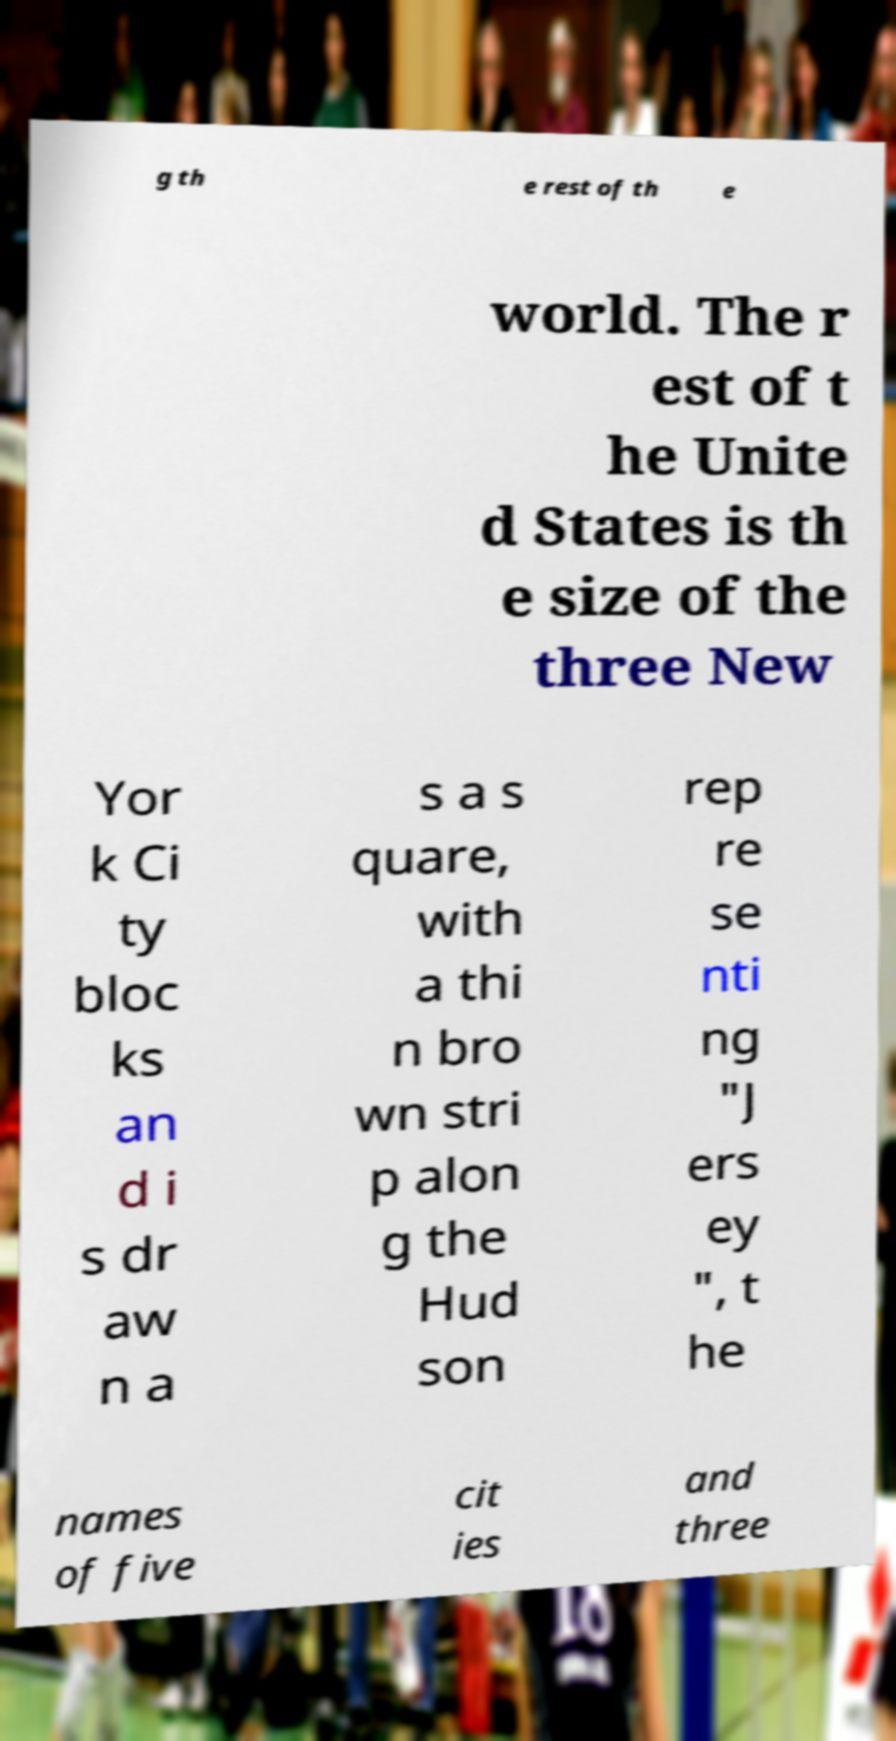Can you accurately transcribe the text from the provided image for me? g th e rest of th e world. The r est of t he Unite d States is th e size of the three New Yor k Ci ty bloc ks an d i s dr aw n a s a s quare, with a thi n bro wn stri p alon g the Hud son rep re se nti ng "J ers ey ", t he names of five cit ies and three 